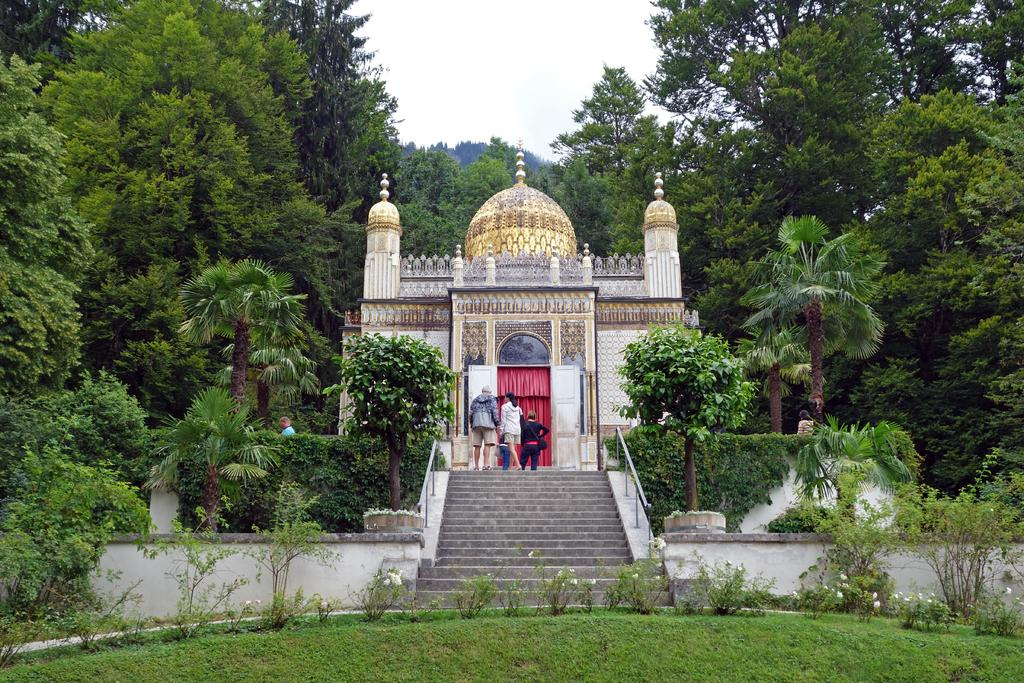What is the main subject of the image? The main subject of the image is an architecture. Are there any people present in the image? Yes, there are people standing in front of the architecture. What can be seen in the surroundings of the architecture? There are many trees and plants around the architecture. What type of hose is being used to water the plants in the image? There is no hose present in the image, and therefore no such activity can be observed. 